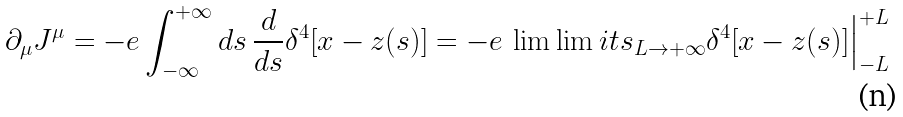<formula> <loc_0><loc_0><loc_500><loc_500>\partial _ { \mu } J ^ { \mu } = - e \int _ { - \infty } ^ { + \infty } d s \, \frac { d } { d s } \delta ^ { 4 } [ x - z ( s ) ] = - e \, \lim \lim i t s _ { L \rightarrow + \infty } \delta ^ { 4 } [ x - z ( s ) ] \Big | _ { - L } ^ { + L }</formula> 